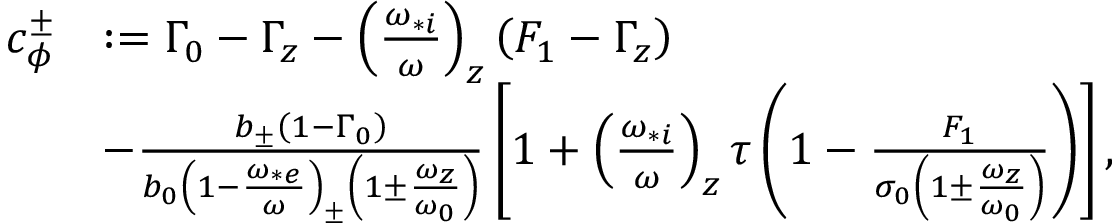<formula> <loc_0><loc_0><loc_500><loc_500>\begin{array} { r l } { c _ { \phi } ^ { \pm } } & { \colon = \Gamma _ { 0 } - \Gamma _ { z } - \left ( \frac { \omega _ { * i } } { \omega } \right ) _ { z } \left ( F _ { 1 } - \Gamma _ { z } \right ) } \\ & { - \frac { b _ { \pm } \left ( 1 - \Gamma _ { 0 } \right ) } { b _ { 0 } \left ( 1 - \frac { \omega _ { * e } } { \omega } \right ) _ { \pm } \left ( 1 \pm \frac { \omega _ { z } } { \omega _ { 0 } } \right ) } \left [ 1 + \left ( \frac { \omega _ { * i } } { \omega } \right ) _ { z } \tau \left ( 1 - \frac { F _ { 1 } } { \sigma _ { 0 } \left ( 1 \pm \frac { \omega _ { z } } { \omega _ { 0 } } \right ) } \right ) \right ] , } \end{array}</formula> 